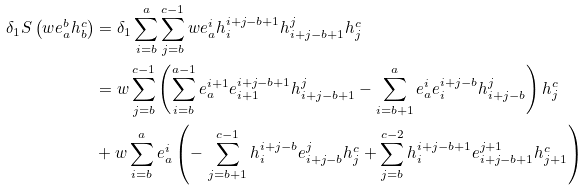<formula> <loc_0><loc_0><loc_500><loc_500>\delta _ { 1 } S \left ( w e _ { a } ^ { b } h _ { b } ^ { c } \right ) & = \delta _ { 1 } \sum _ { i = b } ^ { a } \sum _ { j = b } ^ { c - 1 } w e _ { a } ^ { i } h _ { i } ^ { i + j - b + 1 } h _ { i + j - b + 1 } ^ { j } h _ { j } ^ { c } \\ & = w \sum _ { j = b } ^ { c - 1 } \left ( \sum _ { i = b } ^ { a - 1 } e _ { a } ^ { i + 1 } e _ { i + 1 } ^ { i + j - b + 1 } h _ { i + j - b + 1 } ^ { j } - \sum _ { i = b + 1 } ^ { a } e _ { a } ^ { i } e _ { i } ^ { i + j - b } h _ { i + j - b } ^ { j } \right ) h _ { j } ^ { c } \\ & + w \sum _ { i = b } ^ { a } e _ { a } ^ { i } \left ( - \, \sum _ { j = b + 1 } ^ { c - 1 } h _ { i } ^ { i + j - b } e _ { i + j - b } ^ { j } h _ { j } ^ { c } + \sum _ { j = b } ^ { c - 2 } h _ { i } ^ { i + j - b + 1 } e _ { i + j - b + 1 } ^ { j + 1 } h _ { j + 1 } ^ { c } \right )</formula> 